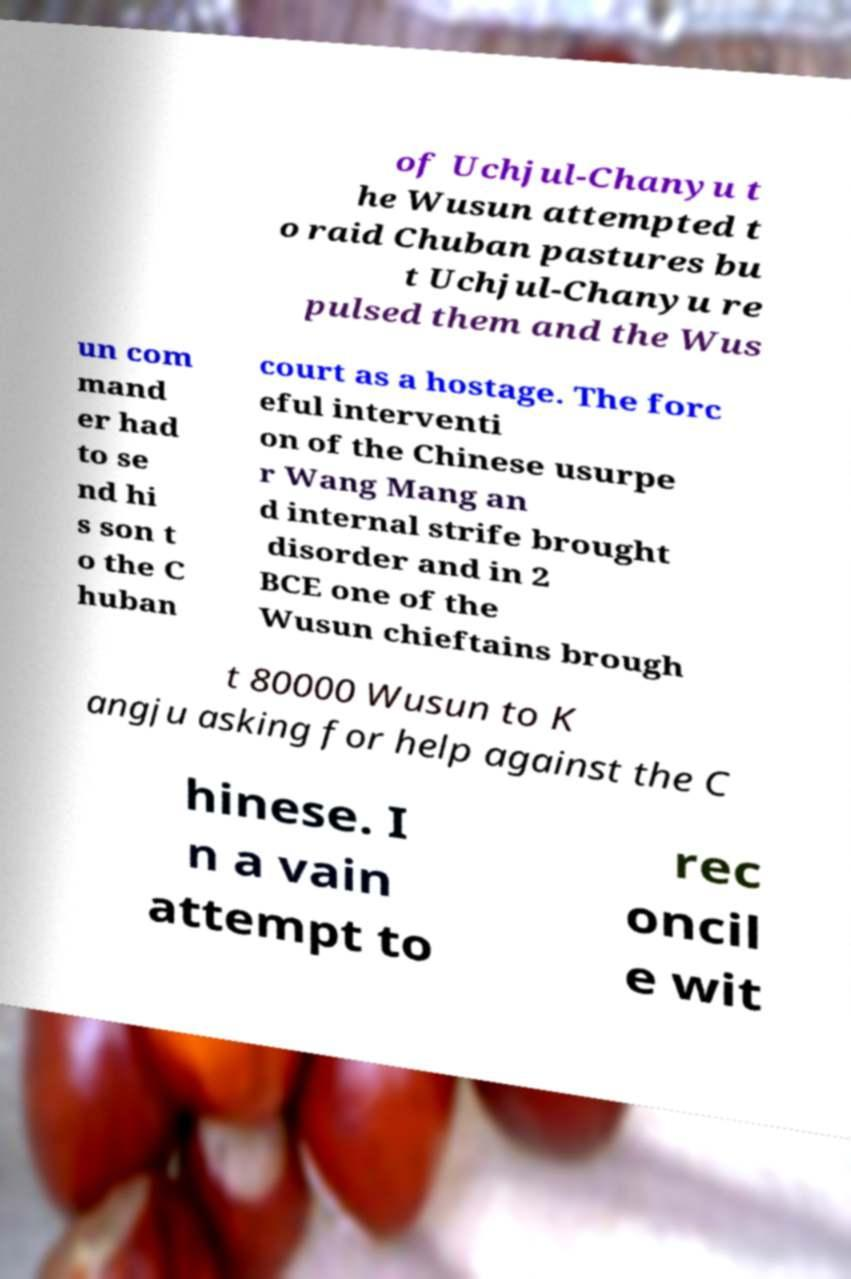For documentation purposes, I need the text within this image transcribed. Could you provide that? of Uchjul-Chanyu t he Wusun attempted t o raid Chuban pastures bu t Uchjul-Chanyu re pulsed them and the Wus un com mand er had to se nd hi s son t o the C huban court as a hostage. The forc eful interventi on of the Chinese usurpe r Wang Mang an d internal strife brought disorder and in 2 BCE one of the Wusun chieftains brough t 80000 Wusun to K angju asking for help against the C hinese. I n a vain attempt to rec oncil e wit 